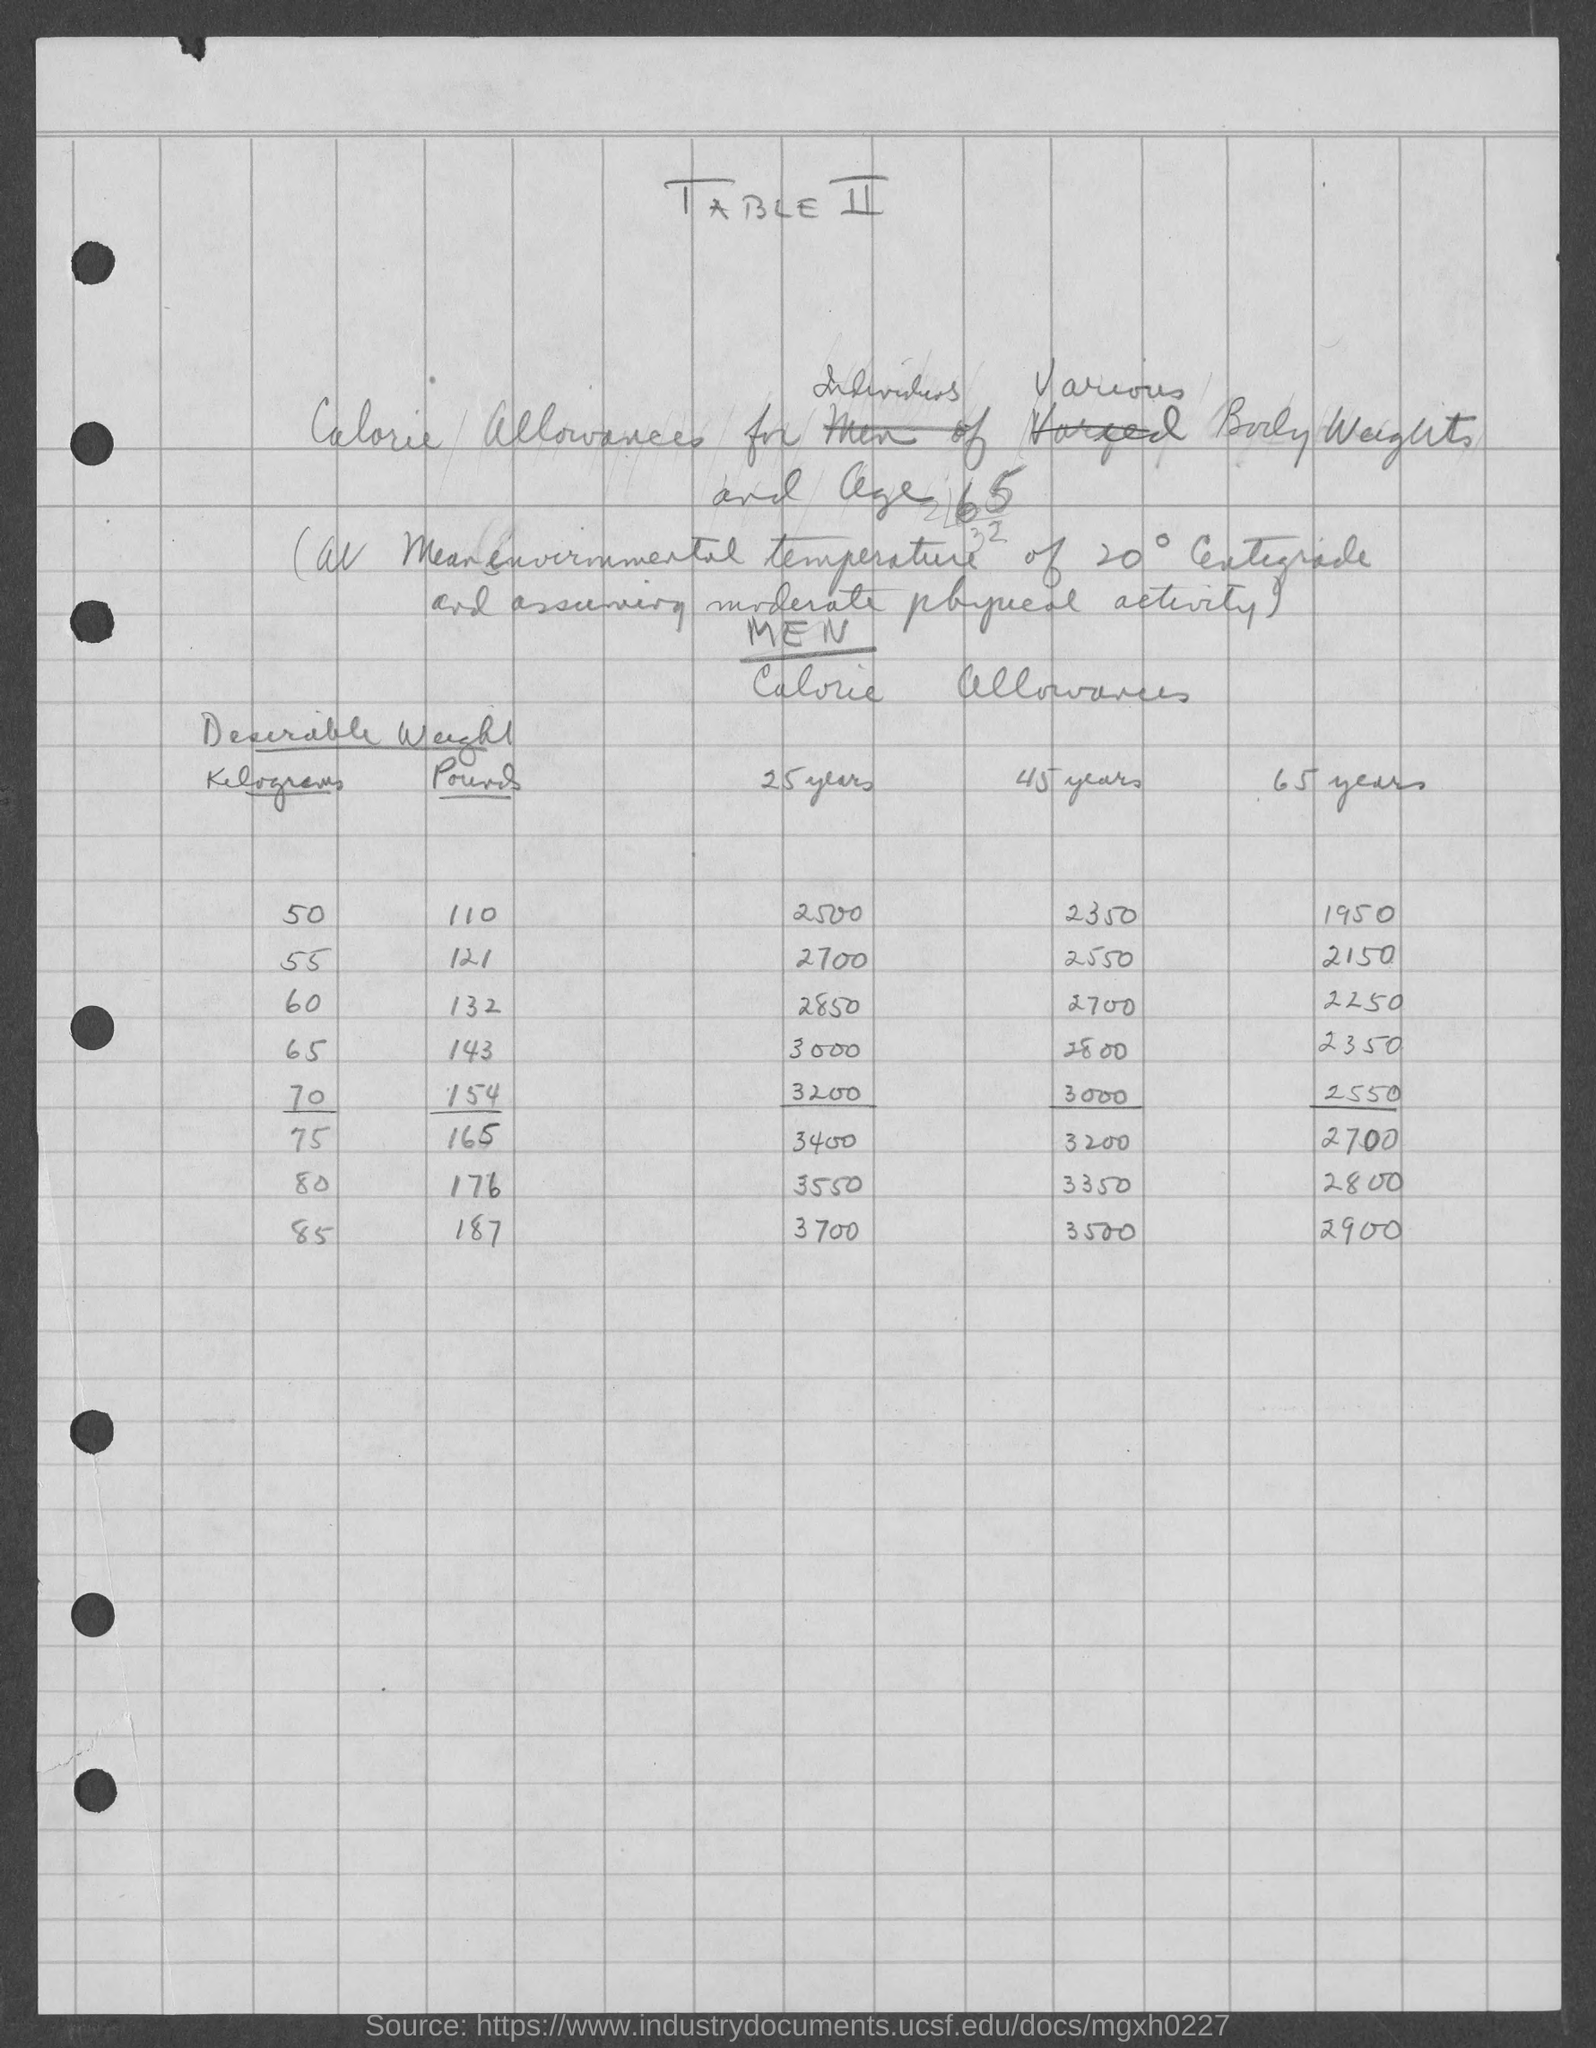Give some essential details in this illustration. The first value for calorie allowances given under the age of 45 is 2350 calories. The first kilogram value mentioned under the desirable weight is 50. The heading of the document is 'What is the heading of the document? TABLE II..' The heading of the first column under the desirable weight category is 'Kilograms'. The heading of the first age group mentioned under 'Calorie allowances' is 25 YEARS OLD. 